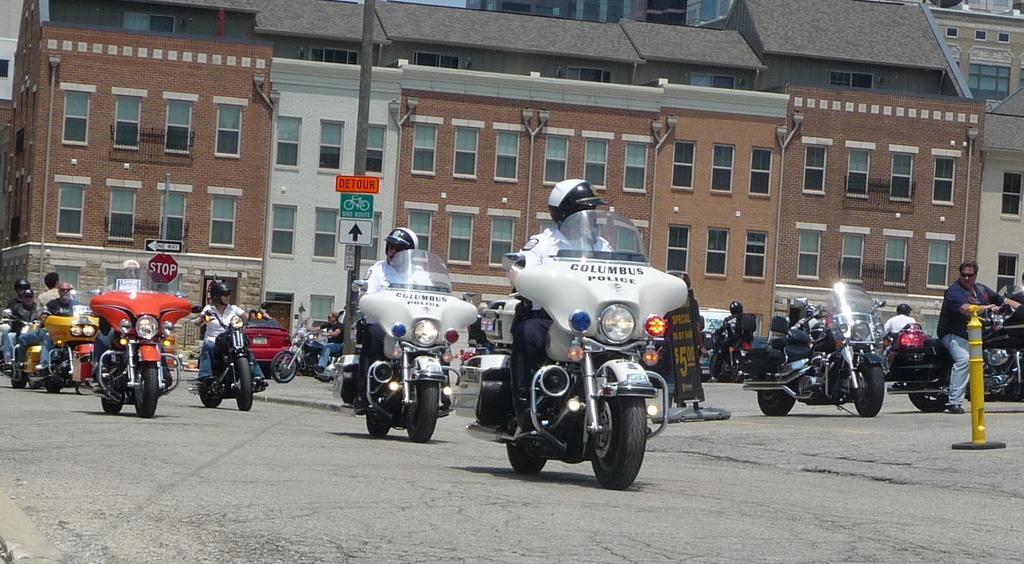Describe this image in one or two sentences. This picture shows a group of people riding their motorcycles and we see few buildings on their back. 